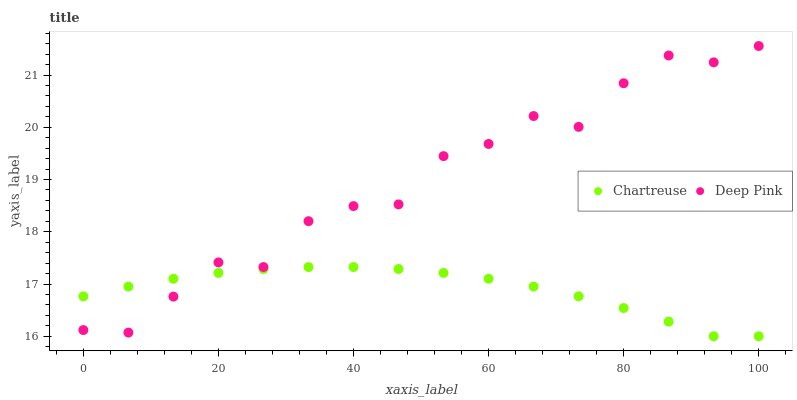Does Chartreuse have the minimum area under the curve?
Answer yes or no. Yes. Does Deep Pink have the maximum area under the curve?
Answer yes or no. Yes. Does Deep Pink have the minimum area under the curve?
Answer yes or no. No. Is Chartreuse the smoothest?
Answer yes or no. Yes. Is Deep Pink the roughest?
Answer yes or no. Yes. Is Deep Pink the smoothest?
Answer yes or no. No. Does Chartreuse have the lowest value?
Answer yes or no. Yes. Does Deep Pink have the lowest value?
Answer yes or no. No. Does Deep Pink have the highest value?
Answer yes or no. Yes. Does Deep Pink intersect Chartreuse?
Answer yes or no. Yes. Is Deep Pink less than Chartreuse?
Answer yes or no. No. Is Deep Pink greater than Chartreuse?
Answer yes or no. No. 